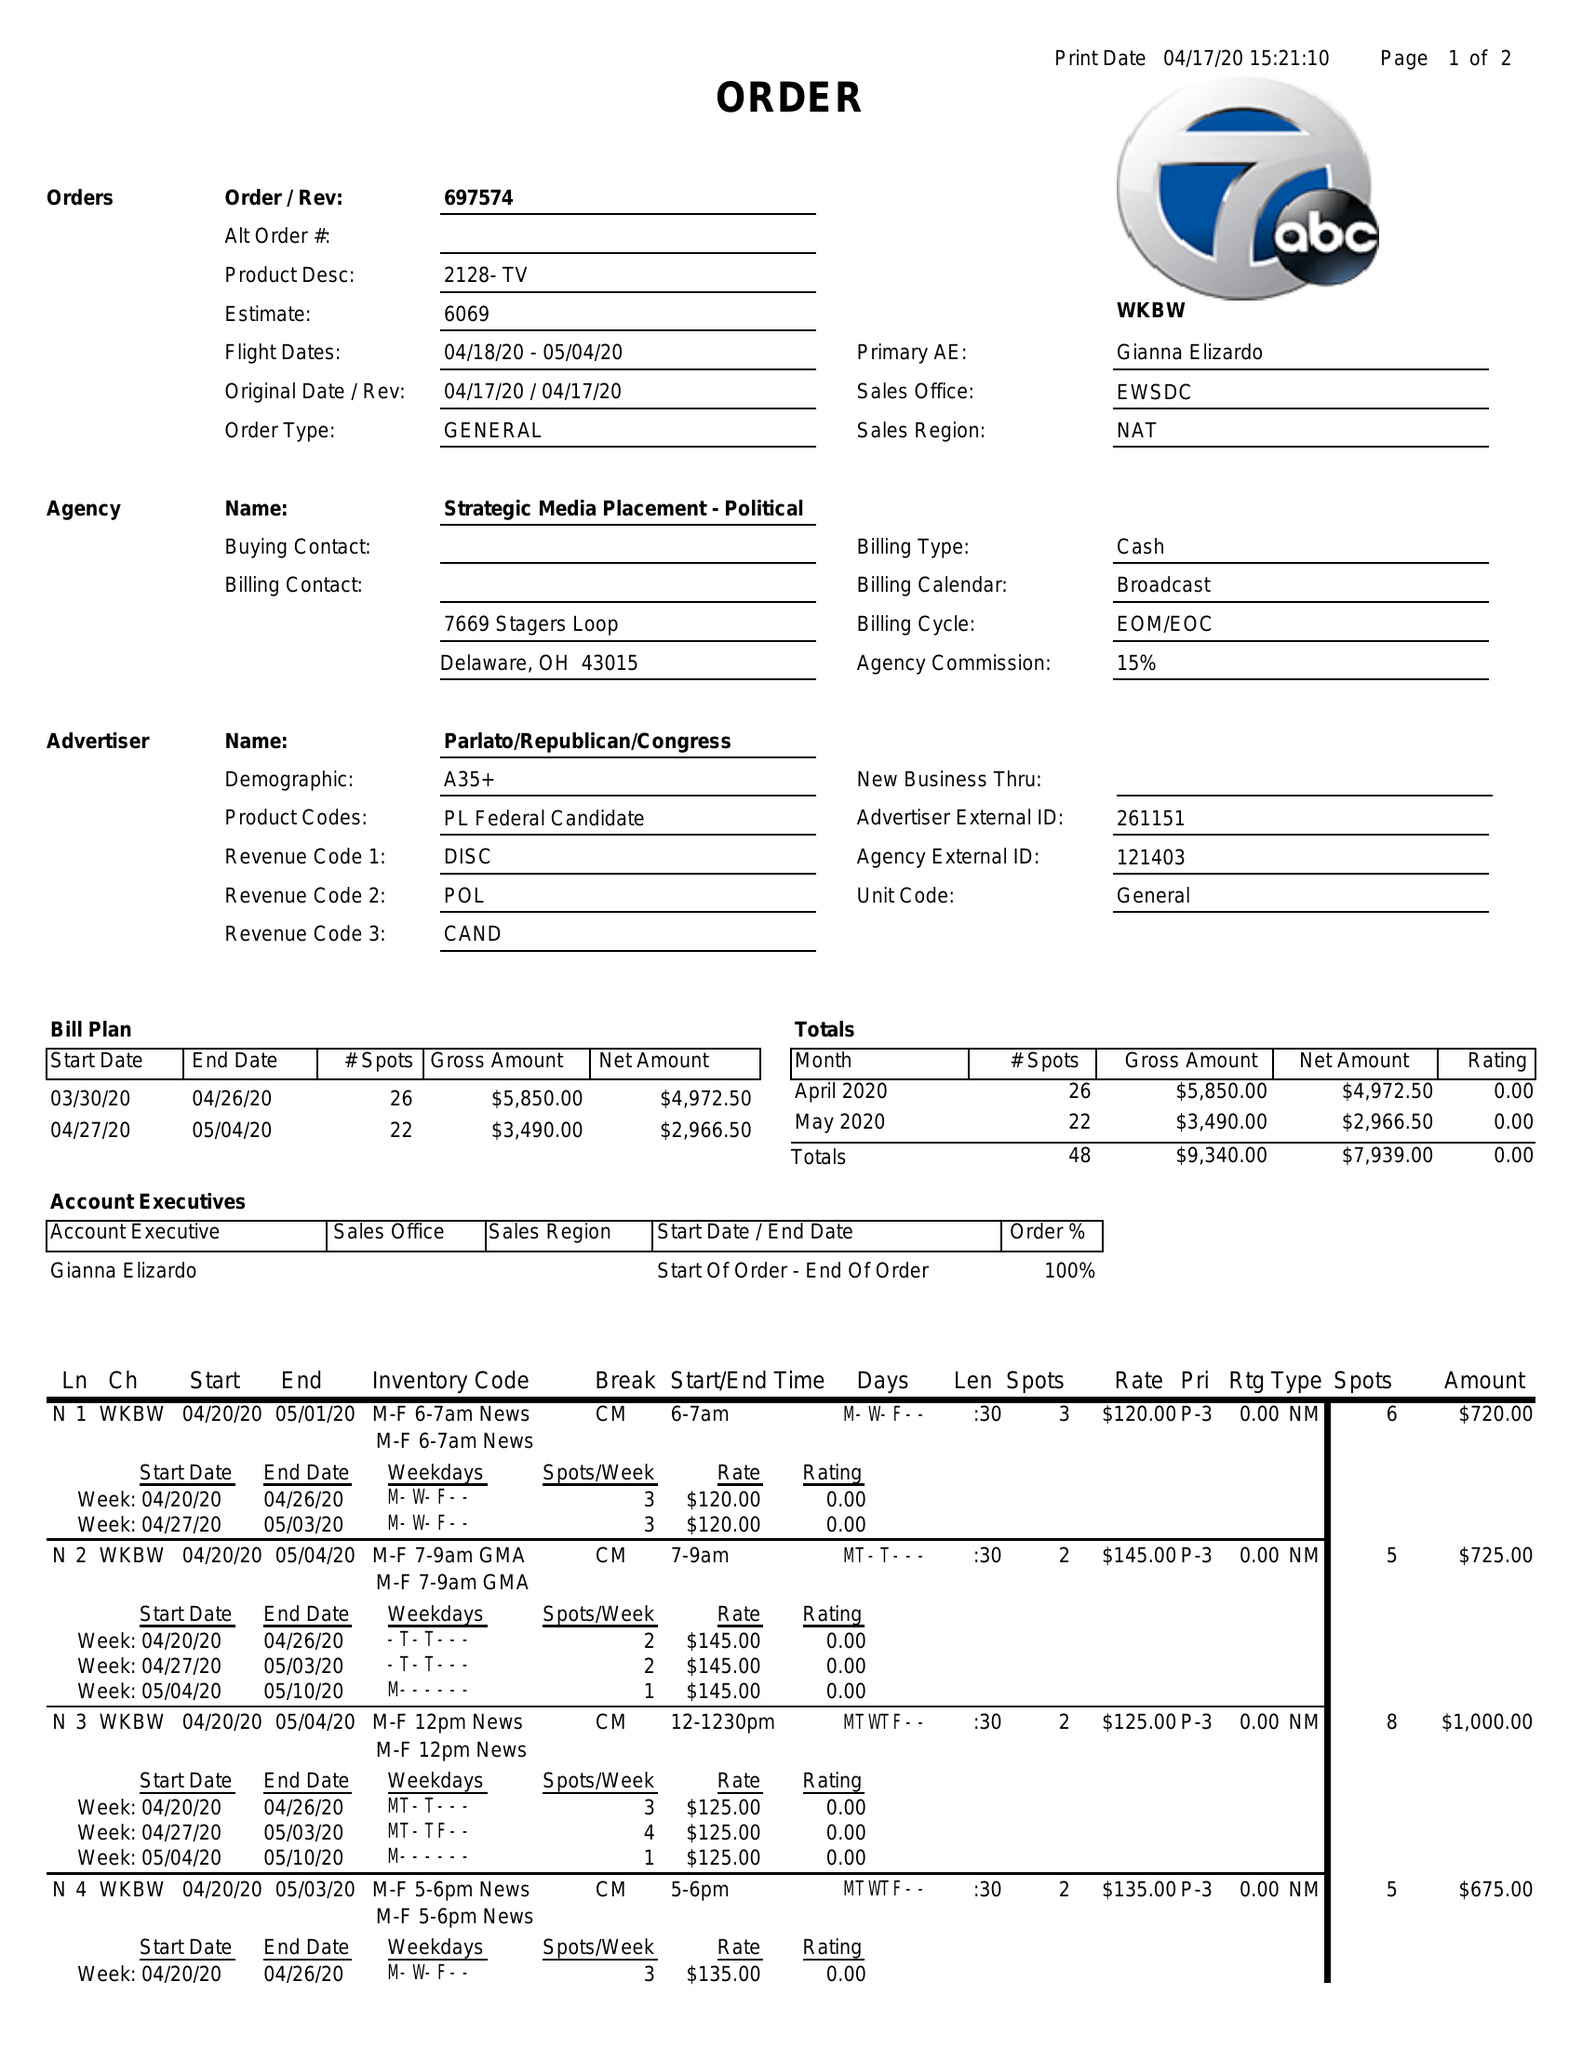What is the value for the advertiser?
Answer the question using a single word or phrase. PARLATO/REPUBLICAN/CONGRESS 